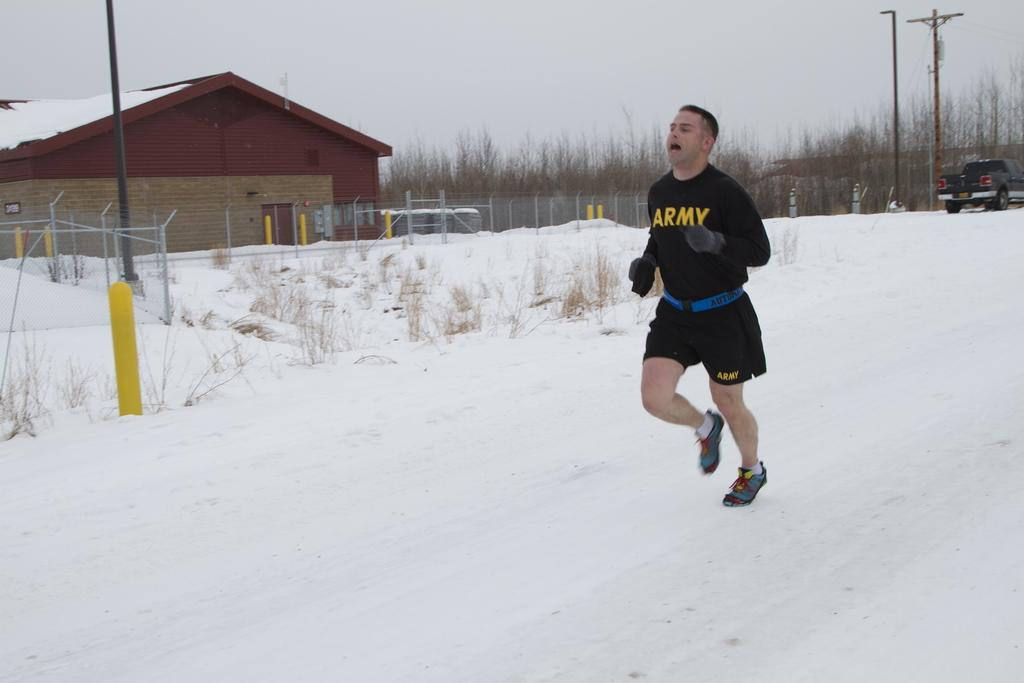<image>
Render a clear and concise summary of the photo. the word army is on the shirt of a man running in snow 